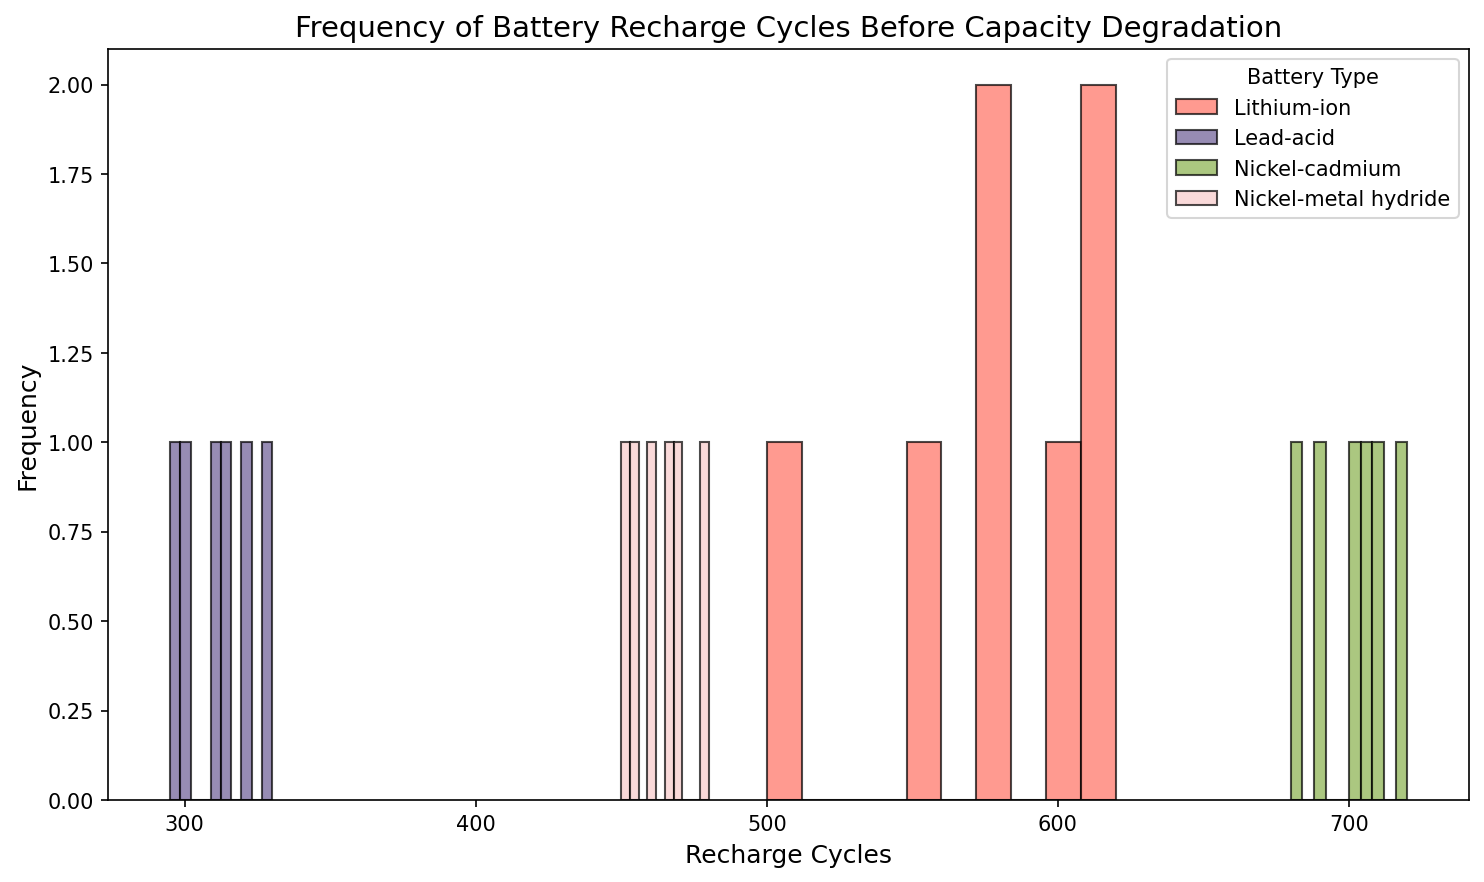Which battery type has the highest average number of recharge cycles before capacity degradation? To find the average, we sum the recharge cycles for each battery type and divide by the number of data points for that type. For Lithium-ion: (500 + 600 + 550 + 580 + 620 + 610 + 575)/7 ≈ 576.43. For Lead-acid: (300 + 320 + 310 + 330 + 295 + 315)/6 ≈ 311.67. For Nickel-cadmium: (700 + 720 + 690 + 680 + 710 + 705)/6 ≈ 701.67. For Nickel-metal hydride: (450 + 470 + 460 + 480 + 455 + 465)/6 ≈ 463.33. Nickel-cadmium has the highest average.
Answer: Nickel-cadmium Which battery type appears most frequently within the highest bin range? Observe the histogram to see which battery type has the tallest bar in the highest bin range of recharge cycles. Assuming the bin ranges go up to 720, Nickel-cadmium appears most frequently in the highest range.
Answer: Nickel-cadmium What is the range of recharge cycles for Lead-acid batteries shown in the figure? Subtract the minimum recharge cycle from the maximum recharge cycle for Lead-acid batteries. The data for Lead-acid ranges from 295 to 330 cycles. Hence, the range is 330 - 295 = 35.
Answer: 35 Which battery type has the least variation in recharge cycles, visually? The variation can be estimated by the spread of the histogram bars. Narrower spreads indicate less variation. Visually, Lead-acid batteries show the least variation as their bars are clustered closely together.
Answer: Lead-acid How does the frequency of Nickel-cadmium recharge cycles compare to that of Lithium-ion cycles in the 700 bin range? Check the height of the bars in the 700 bin range for both Nickel-cadmium and Lithium-ion. Nickel-cadmium has higher frequency bars at this range, indicating it occurs more frequently.
Answer: Nickel-cadmium What can be inferred about the life cycles of these battery types from the histograms? Compare the spread and concentrations of the recharge cycles for each battery type. Narrower and taller histograms suggest more consistency and possibly longer life cycles before degradation. Lead-acid has a narrow range (likely shorter life cycles), while Nickel-cadmium has a wider spread (longer life cycles).
Answer: Lead-acid has shorter, more consistent life cycles; Nickel-cadmium has longer and varied life cycles 